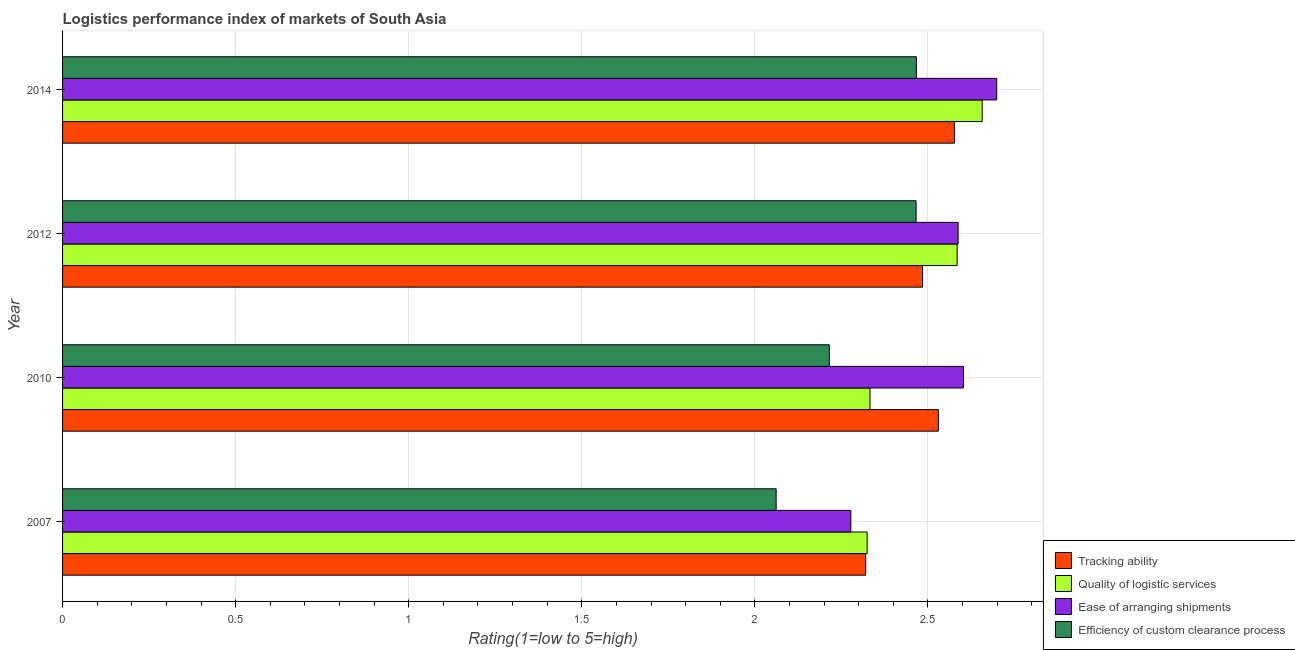How many different coloured bars are there?
Offer a very short reply. 4. How many groups of bars are there?
Provide a succinct answer. 4. How many bars are there on the 3rd tick from the bottom?
Provide a succinct answer. 4. What is the label of the 1st group of bars from the top?
Provide a succinct answer. 2014. What is the lpi rating of tracking ability in 2012?
Your answer should be very brief. 2.48. Across all years, what is the maximum lpi rating of ease of arranging shipments?
Keep it short and to the point. 2.7. Across all years, what is the minimum lpi rating of ease of arranging shipments?
Your answer should be very brief. 2.28. What is the total lpi rating of efficiency of custom clearance process in the graph?
Your answer should be compact. 9.21. What is the difference between the lpi rating of efficiency of custom clearance process in 2012 and that in 2014?
Your response must be concise. -0. What is the difference between the lpi rating of efficiency of custom clearance process in 2014 and the lpi rating of tracking ability in 2007?
Your answer should be compact. 0.15. What is the average lpi rating of quality of logistic services per year?
Ensure brevity in your answer.  2.47. In the year 2010, what is the difference between the lpi rating of quality of logistic services and lpi rating of efficiency of custom clearance process?
Make the answer very short. 0.12. In how many years, is the lpi rating of ease of arranging shipments greater than 2.5 ?
Provide a short and direct response. 3. What is the ratio of the lpi rating of efficiency of custom clearance process in 2007 to that in 2014?
Your response must be concise. 0.84. Is the lpi rating of tracking ability in 2012 less than that in 2014?
Offer a very short reply. Yes. What is the difference between the highest and the second highest lpi rating of ease of arranging shipments?
Provide a succinct answer. 0.1. What is the difference between the highest and the lowest lpi rating of tracking ability?
Provide a short and direct response. 0.26. In how many years, is the lpi rating of ease of arranging shipments greater than the average lpi rating of ease of arranging shipments taken over all years?
Make the answer very short. 3. Is it the case that in every year, the sum of the lpi rating of quality of logistic services and lpi rating of efficiency of custom clearance process is greater than the sum of lpi rating of ease of arranging shipments and lpi rating of tracking ability?
Ensure brevity in your answer.  Yes. What does the 4th bar from the top in 2012 represents?
Ensure brevity in your answer.  Tracking ability. What does the 4th bar from the bottom in 2010 represents?
Your answer should be compact. Efficiency of custom clearance process. Is it the case that in every year, the sum of the lpi rating of tracking ability and lpi rating of quality of logistic services is greater than the lpi rating of ease of arranging shipments?
Your response must be concise. Yes. Are all the bars in the graph horizontal?
Give a very brief answer. Yes. What is the difference between two consecutive major ticks on the X-axis?
Offer a terse response. 0.5. Are the values on the major ticks of X-axis written in scientific E-notation?
Make the answer very short. No. Where does the legend appear in the graph?
Your answer should be compact. Bottom right. How are the legend labels stacked?
Ensure brevity in your answer.  Vertical. What is the title of the graph?
Your response must be concise. Logistics performance index of markets of South Asia. What is the label or title of the X-axis?
Provide a short and direct response. Rating(1=low to 5=high). What is the label or title of the Y-axis?
Provide a succinct answer. Year. What is the Rating(1=low to 5=high) in Tracking ability in 2007?
Your response must be concise. 2.32. What is the Rating(1=low to 5=high) of Quality of logistic services in 2007?
Offer a very short reply. 2.32. What is the Rating(1=low to 5=high) in Ease of arranging shipments in 2007?
Your answer should be very brief. 2.28. What is the Rating(1=low to 5=high) of Efficiency of custom clearance process in 2007?
Offer a terse response. 2.06. What is the Rating(1=low to 5=high) in Tracking ability in 2010?
Give a very brief answer. 2.53. What is the Rating(1=low to 5=high) in Quality of logistic services in 2010?
Your answer should be compact. 2.33. What is the Rating(1=low to 5=high) of Ease of arranging shipments in 2010?
Provide a succinct answer. 2.6. What is the Rating(1=low to 5=high) in Efficiency of custom clearance process in 2010?
Offer a terse response. 2.21. What is the Rating(1=low to 5=high) of Tracking ability in 2012?
Ensure brevity in your answer.  2.48. What is the Rating(1=low to 5=high) in Quality of logistic services in 2012?
Your response must be concise. 2.58. What is the Rating(1=low to 5=high) in Ease of arranging shipments in 2012?
Your response must be concise. 2.59. What is the Rating(1=low to 5=high) of Efficiency of custom clearance process in 2012?
Make the answer very short. 2.47. What is the Rating(1=low to 5=high) in Tracking ability in 2014?
Provide a succinct answer. 2.58. What is the Rating(1=low to 5=high) in Quality of logistic services in 2014?
Provide a short and direct response. 2.66. What is the Rating(1=low to 5=high) in Ease of arranging shipments in 2014?
Your answer should be very brief. 2.7. What is the Rating(1=low to 5=high) in Efficiency of custom clearance process in 2014?
Give a very brief answer. 2.47. Across all years, what is the maximum Rating(1=low to 5=high) in Tracking ability?
Ensure brevity in your answer.  2.58. Across all years, what is the maximum Rating(1=low to 5=high) in Quality of logistic services?
Make the answer very short. 2.66. Across all years, what is the maximum Rating(1=low to 5=high) in Ease of arranging shipments?
Keep it short and to the point. 2.7. Across all years, what is the maximum Rating(1=low to 5=high) in Efficiency of custom clearance process?
Offer a terse response. 2.47. Across all years, what is the minimum Rating(1=low to 5=high) in Tracking ability?
Provide a succinct answer. 2.32. Across all years, what is the minimum Rating(1=low to 5=high) of Quality of logistic services?
Your answer should be very brief. 2.32. Across all years, what is the minimum Rating(1=low to 5=high) in Ease of arranging shipments?
Ensure brevity in your answer.  2.28. Across all years, what is the minimum Rating(1=low to 5=high) in Efficiency of custom clearance process?
Provide a short and direct response. 2.06. What is the total Rating(1=low to 5=high) in Tracking ability in the graph?
Provide a short and direct response. 9.91. What is the total Rating(1=low to 5=high) of Quality of logistic services in the graph?
Your response must be concise. 9.9. What is the total Rating(1=low to 5=high) in Ease of arranging shipments in the graph?
Provide a short and direct response. 10.17. What is the total Rating(1=low to 5=high) in Efficiency of custom clearance process in the graph?
Offer a terse response. 9.21. What is the difference between the Rating(1=low to 5=high) in Tracking ability in 2007 and that in 2010?
Your response must be concise. -0.21. What is the difference between the Rating(1=low to 5=high) of Quality of logistic services in 2007 and that in 2010?
Give a very brief answer. -0.01. What is the difference between the Rating(1=low to 5=high) of Ease of arranging shipments in 2007 and that in 2010?
Ensure brevity in your answer.  -0.33. What is the difference between the Rating(1=low to 5=high) in Efficiency of custom clearance process in 2007 and that in 2010?
Offer a terse response. -0.15. What is the difference between the Rating(1=low to 5=high) in Tracking ability in 2007 and that in 2012?
Keep it short and to the point. -0.16. What is the difference between the Rating(1=low to 5=high) in Quality of logistic services in 2007 and that in 2012?
Ensure brevity in your answer.  -0.26. What is the difference between the Rating(1=low to 5=high) in Ease of arranging shipments in 2007 and that in 2012?
Offer a very short reply. -0.31. What is the difference between the Rating(1=low to 5=high) of Efficiency of custom clearance process in 2007 and that in 2012?
Keep it short and to the point. -0.4. What is the difference between the Rating(1=low to 5=high) in Tracking ability in 2007 and that in 2014?
Ensure brevity in your answer.  -0.26. What is the difference between the Rating(1=low to 5=high) of Quality of logistic services in 2007 and that in 2014?
Your answer should be very brief. -0.33. What is the difference between the Rating(1=low to 5=high) in Ease of arranging shipments in 2007 and that in 2014?
Make the answer very short. -0.42. What is the difference between the Rating(1=low to 5=high) in Efficiency of custom clearance process in 2007 and that in 2014?
Your answer should be compact. -0.41. What is the difference between the Rating(1=low to 5=high) of Tracking ability in 2010 and that in 2012?
Offer a terse response. 0.05. What is the difference between the Rating(1=low to 5=high) in Quality of logistic services in 2010 and that in 2012?
Keep it short and to the point. -0.25. What is the difference between the Rating(1=low to 5=high) in Ease of arranging shipments in 2010 and that in 2012?
Make the answer very short. 0.02. What is the difference between the Rating(1=low to 5=high) of Efficiency of custom clearance process in 2010 and that in 2012?
Your answer should be compact. -0.25. What is the difference between the Rating(1=low to 5=high) of Tracking ability in 2010 and that in 2014?
Offer a terse response. -0.05. What is the difference between the Rating(1=low to 5=high) in Quality of logistic services in 2010 and that in 2014?
Make the answer very short. -0.32. What is the difference between the Rating(1=low to 5=high) of Ease of arranging shipments in 2010 and that in 2014?
Give a very brief answer. -0.1. What is the difference between the Rating(1=low to 5=high) of Efficiency of custom clearance process in 2010 and that in 2014?
Your response must be concise. -0.25. What is the difference between the Rating(1=low to 5=high) in Tracking ability in 2012 and that in 2014?
Make the answer very short. -0.09. What is the difference between the Rating(1=low to 5=high) in Quality of logistic services in 2012 and that in 2014?
Provide a short and direct response. -0.07. What is the difference between the Rating(1=low to 5=high) in Ease of arranging shipments in 2012 and that in 2014?
Offer a very short reply. -0.11. What is the difference between the Rating(1=low to 5=high) in Efficiency of custom clearance process in 2012 and that in 2014?
Keep it short and to the point. -0. What is the difference between the Rating(1=low to 5=high) in Tracking ability in 2007 and the Rating(1=low to 5=high) in Quality of logistic services in 2010?
Provide a short and direct response. -0.01. What is the difference between the Rating(1=low to 5=high) in Tracking ability in 2007 and the Rating(1=low to 5=high) in Ease of arranging shipments in 2010?
Give a very brief answer. -0.28. What is the difference between the Rating(1=low to 5=high) of Tracking ability in 2007 and the Rating(1=low to 5=high) of Efficiency of custom clearance process in 2010?
Give a very brief answer. 0.1. What is the difference between the Rating(1=low to 5=high) in Quality of logistic services in 2007 and the Rating(1=low to 5=high) in Ease of arranging shipments in 2010?
Make the answer very short. -0.28. What is the difference between the Rating(1=low to 5=high) of Quality of logistic services in 2007 and the Rating(1=low to 5=high) of Efficiency of custom clearance process in 2010?
Your answer should be very brief. 0.11. What is the difference between the Rating(1=low to 5=high) in Ease of arranging shipments in 2007 and the Rating(1=low to 5=high) in Efficiency of custom clearance process in 2010?
Provide a succinct answer. 0.06. What is the difference between the Rating(1=low to 5=high) of Tracking ability in 2007 and the Rating(1=low to 5=high) of Quality of logistic services in 2012?
Give a very brief answer. -0.26. What is the difference between the Rating(1=low to 5=high) in Tracking ability in 2007 and the Rating(1=low to 5=high) in Ease of arranging shipments in 2012?
Provide a succinct answer. -0.27. What is the difference between the Rating(1=low to 5=high) of Tracking ability in 2007 and the Rating(1=low to 5=high) of Efficiency of custom clearance process in 2012?
Your answer should be compact. -0.15. What is the difference between the Rating(1=low to 5=high) in Quality of logistic services in 2007 and the Rating(1=low to 5=high) in Ease of arranging shipments in 2012?
Give a very brief answer. -0.26. What is the difference between the Rating(1=low to 5=high) in Quality of logistic services in 2007 and the Rating(1=low to 5=high) in Efficiency of custom clearance process in 2012?
Provide a short and direct response. -0.14. What is the difference between the Rating(1=low to 5=high) in Ease of arranging shipments in 2007 and the Rating(1=low to 5=high) in Efficiency of custom clearance process in 2012?
Make the answer very short. -0.19. What is the difference between the Rating(1=low to 5=high) of Tracking ability in 2007 and the Rating(1=low to 5=high) of Quality of logistic services in 2014?
Your answer should be very brief. -0.34. What is the difference between the Rating(1=low to 5=high) of Tracking ability in 2007 and the Rating(1=low to 5=high) of Ease of arranging shipments in 2014?
Ensure brevity in your answer.  -0.38. What is the difference between the Rating(1=low to 5=high) in Tracking ability in 2007 and the Rating(1=low to 5=high) in Efficiency of custom clearance process in 2014?
Your answer should be compact. -0.15. What is the difference between the Rating(1=low to 5=high) of Quality of logistic services in 2007 and the Rating(1=low to 5=high) of Ease of arranging shipments in 2014?
Provide a short and direct response. -0.37. What is the difference between the Rating(1=low to 5=high) in Quality of logistic services in 2007 and the Rating(1=low to 5=high) in Efficiency of custom clearance process in 2014?
Keep it short and to the point. -0.14. What is the difference between the Rating(1=low to 5=high) in Ease of arranging shipments in 2007 and the Rating(1=low to 5=high) in Efficiency of custom clearance process in 2014?
Keep it short and to the point. -0.19. What is the difference between the Rating(1=low to 5=high) of Tracking ability in 2010 and the Rating(1=low to 5=high) of Quality of logistic services in 2012?
Offer a terse response. -0.05. What is the difference between the Rating(1=low to 5=high) of Tracking ability in 2010 and the Rating(1=low to 5=high) of Ease of arranging shipments in 2012?
Offer a very short reply. -0.06. What is the difference between the Rating(1=low to 5=high) of Tracking ability in 2010 and the Rating(1=low to 5=high) of Efficiency of custom clearance process in 2012?
Keep it short and to the point. 0.06. What is the difference between the Rating(1=low to 5=high) of Quality of logistic services in 2010 and the Rating(1=low to 5=high) of Ease of arranging shipments in 2012?
Offer a very short reply. -0.25. What is the difference between the Rating(1=low to 5=high) in Quality of logistic services in 2010 and the Rating(1=low to 5=high) in Efficiency of custom clearance process in 2012?
Your answer should be very brief. -0.13. What is the difference between the Rating(1=low to 5=high) of Ease of arranging shipments in 2010 and the Rating(1=low to 5=high) of Efficiency of custom clearance process in 2012?
Provide a short and direct response. 0.14. What is the difference between the Rating(1=low to 5=high) in Tracking ability in 2010 and the Rating(1=low to 5=high) in Quality of logistic services in 2014?
Keep it short and to the point. -0.13. What is the difference between the Rating(1=low to 5=high) in Tracking ability in 2010 and the Rating(1=low to 5=high) in Ease of arranging shipments in 2014?
Provide a succinct answer. -0.17. What is the difference between the Rating(1=low to 5=high) of Tracking ability in 2010 and the Rating(1=low to 5=high) of Efficiency of custom clearance process in 2014?
Your answer should be very brief. 0.06. What is the difference between the Rating(1=low to 5=high) in Quality of logistic services in 2010 and the Rating(1=low to 5=high) in Ease of arranging shipments in 2014?
Offer a very short reply. -0.37. What is the difference between the Rating(1=low to 5=high) in Quality of logistic services in 2010 and the Rating(1=low to 5=high) in Efficiency of custom clearance process in 2014?
Make the answer very short. -0.13. What is the difference between the Rating(1=low to 5=high) of Ease of arranging shipments in 2010 and the Rating(1=low to 5=high) of Efficiency of custom clearance process in 2014?
Your response must be concise. 0.14. What is the difference between the Rating(1=low to 5=high) of Tracking ability in 2012 and the Rating(1=low to 5=high) of Quality of logistic services in 2014?
Offer a terse response. -0.17. What is the difference between the Rating(1=low to 5=high) of Tracking ability in 2012 and the Rating(1=low to 5=high) of Ease of arranging shipments in 2014?
Provide a short and direct response. -0.21. What is the difference between the Rating(1=low to 5=high) in Tracking ability in 2012 and the Rating(1=low to 5=high) in Efficiency of custom clearance process in 2014?
Make the answer very short. 0.02. What is the difference between the Rating(1=low to 5=high) in Quality of logistic services in 2012 and the Rating(1=low to 5=high) in Ease of arranging shipments in 2014?
Provide a succinct answer. -0.11. What is the difference between the Rating(1=low to 5=high) in Quality of logistic services in 2012 and the Rating(1=low to 5=high) in Efficiency of custom clearance process in 2014?
Offer a very short reply. 0.12. What is the difference between the Rating(1=low to 5=high) of Ease of arranging shipments in 2012 and the Rating(1=low to 5=high) of Efficiency of custom clearance process in 2014?
Offer a very short reply. 0.12. What is the average Rating(1=low to 5=high) in Tracking ability per year?
Provide a short and direct response. 2.48. What is the average Rating(1=low to 5=high) of Quality of logistic services per year?
Make the answer very short. 2.47. What is the average Rating(1=low to 5=high) in Ease of arranging shipments per year?
Offer a terse response. 2.54. What is the average Rating(1=low to 5=high) in Efficiency of custom clearance process per year?
Give a very brief answer. 2.3. In the year 2007, what is the difference between the Rating(1=low to 5=high) in Tracking ability and Rating(1=low to 5=high) in Quality of logistic services?
Your response must be concise. -0. In the year 2007, what is the difference between the Rating(1=low to 5=high) in Tracking ability and Rating(1=low to 5=high) in Ease of arranging shipments?
Offer a very short reply. 0.04. In the year 2007, what is the difference between the Rating(1=low to 5=high) of Tracking ability and Rating(1=low to 5=high) of Efficiency of custom clearance process?
Keep it short and to the point. 0.26. In the year 2007, what is the difference between the Rating(1=low to 5=high) of Quality of logistic services and Rating(1=low to 5=high) of Ease of arranging shipments?
Give a very brief answer. 0.05. In the year 2007, what is the difference between the Rating(1=low to 5=high) of Quality of logistic services and Rating(1=low to 5=high) of Efficiency of custom clearance process?
Your answer should be very brief. 0.26. In the year 2007, what is the difference between the Rating(1=low to 5=high) of Ease of arranging shipments and Rating(1=low to 5=high) of Efficiency of custom clearance process?
Make the answer very short. 0.22. In the year 2010, what is the difference between the Rating(1=low to 5=high) in Tracking ability and Rating(1=low to 5=high) in Quality of logistic services?
Keep it short and to the point. 0.2. In the year 2010, what is the difference between the Rating(1=low to 5=high) in Tracking ability and Rating(1=low to 5=high) in Ease of arranging shipments?
Provide a short and direct response. -0.07. In the year 2010, what is the difference between the Rating(1=low to 5=high) of Tracking ability and Rating(1=low to 5=high) of Efficiency of custom clearance process?
Provide a short and direct response. 0.32. In the year 2010, what is the difference between the Rating(1=low to 5=high) of Quality of logistic services and Rating(1=low to 5=high) of Ease of arranging shipments?
Offer a terse response. -0.27. In the year 2010, what is the difference between the Rating(1=low to 5=high) in Quality of logistic services and Rating(1=low to 5=high) in Efficiency of custom clearance process?
Your response must be concise. 0.12. In the year 2010, what is the difference between the Rating(1=low to 5=high) of Ease of arranging shipments and Rating(1=low to 5=high) of Efficiency of custom clearance process?
Provide a succinct answer. 0.39. In the year 2012, what is the difference between the Rating(1=low to 5=high) in Tracking ability and Rating(1=low to 5=high) in Quality of logistic services?
Keep it short and to the point. -0.1. In the year 2012, what is the difference between the Rating(1=low to 5=high) of Tracking ability and Rating(1=low to 5=high) of Ease of arranging shipments?
Make the answer very short. -0.1. In the year 2012, what is the difference between the Rating(1=low to 5=high) of Tracking ability and Rating(1=low to 5=high) of Efficiency of custom clearance process?
Offer a very short reply. 0.02. In the year 2012, what is the difference between the Rating(1=low to 5=high) of Quality of logistic services and Rating(1=low to 5=high) of Ease of arranging shipments?
Your response must be concise. -0. In the year 2012, what is the difference between the Rating(1=low to 5=high) of Quality of logistic services and Rating(1=low to 5=high) of Efficiency of custom clearance process?
Provide a short and direct response. 0.12. In the year 2012, what is the difference between the Rating(1=low to 5=high) in Ease of arranging shipments and Rating(1=low to 5=high) in Efficiency of custom clearance process?
Your response must be concise. 0.12. In the year 2014, what is the difference between the Rating(1=low to 5=high) of Tracking ability and Rating(1=low to 5=high) of Quality of logistic services?
Offer a very short reply. -0.08. In the year 2014, what is the difference between the Rating(1=low to 5=high) in Tracking ability and Rating(1=low to 5=high) in Ease of arranging shipments?
Keep it short and to the point. -0.12. In the year 2014, what is the difference between the Rating(1=low to 5=high) of Tracking ability and Rating(1=low to 5=high) of Efficiency of custom clearance process?
Keep it short and to the point. 0.11. In the year 2014, what is the difference between the Rating(1=low to 5=high) of Quality of logistic services and Rating(1=low to 5=high) of Ease of arranging shipments?
Provide a succinct answer. -0.04. In the year 2014, what is the difference between the Rating(1=low to 5=high) of Quality of logistic services and Rating(1=low to 5=high) of Efficiency of custom clearance process?
Make the answer very short. 0.19. In the year 2014, what is the difference between the Rating(1=low to 5=high) in Ease of arranging shipments and Rating(1=low to 5=high) in Efficiency of custom clearance process?
Provide a succinct answer. 0.23. What is the ratio of the Rating(1=low to 5=high) of Tracking ability in 2007 to that in 2010?
Ensure brevity in your answer.  0.92. What is the ratio of the Rating(1=low to 5=high) in Ease of arranging shipments in 2007 to that in 2010?
Keep it short and to the point. 0.88. What is the ratio of the Rating(1=low to 5=high) of Efficiency of custom clearance process in 2007 to that in 2010?
Your answer should be very brief. 0.93. What is the ratio of the Rating(1=low to 5=high) of Tracking ability in 2007 to that in 2012?
Give a very brief answer. 0.93. What is the ratio of the Rating(1=low to 5=high) in Quality of logistic services in 2007 to that in 2012?
Your answer should be compact. 0.9. What is the ratio of the Rating(1=low to 5=high) in Ease of arranging shipments in 2007 to that in 2012?
Offer a very short reply. 0.88. What is the ratio of the Rating(1=low to 5=high) of Efficiency of custom clearance process in 2007 to that in 2012?
Your response must be concise. 0.84. What is the ratio of the Rating(1=low to 5=high) in Tracking ability in 2007 to that in 2014?
Offer a terse response. 0.9. What is the ratio of the Rating(1=low to 5=high) of Quality of logistic services in 2007 to that in 2014?
Provide a short and direct response. 0.87. What is the ratio of the Rating(1=low to 5=high) of Ease of arranging shipments in 2007 to that in 2014?
Give a very brief answer. 0.84. What is the ratio of the Rating(1=low to 5=high) in Efficiency of custom clearance process in 2007 to that in 2014?
Your response must be concise. 0.84. What is the ratio of the Rating(1=low to 5=high) in Tracking ability in 2010 to that in 2012?
Offer a terse response. 1.02. What is the ratio of the Rating(1=low to 5=high) of Quality of logistic services in 2010 to that in 2012?
Keep it short and to the point. 0.9. What is the ratio of the Rating(1=low to 5=high) in Ease of arranging shipments in 2010 to that in 2012?
Make the answer very short. 1.01. What is the ratio of the Rating(1=low to 5=high) of Efficiency of custom clearance process in 2010 to that in 2012?
Offer a terse response. 0.9. What is the ratio of the Rating(1=low to 5=high) in Quality of logistic services in 2010 to that in 2014?
Provide a succinct answer. 0.88. What is the ratio of the Rating(1=low to 5=high) of Ease of arranging shipments in 2010 to that in 2014?
Your answer should be compact. 0.96. What is the ratio of the Rating(1=low to 5=high) of Efficiency of custom clearance process in 2010 to that in 2014?
Offer a terse response. 0.9. What is the ratio of the Rating(1=low to 5=high) of Quality of logistic services in 2012 to that in 2014?
Your response must be concise. 0.97. What is the ratio of the Rating(1=low to 5=high) in Ease of arranging shipments in 2012 to that in 2014?
Keep it short and to the point. 0.96. What is the ratio of the Rating(1=low to 5=high) of Efficiency of custom clearance process in 2012 to that in 2014?
Keep it short and to the point. 1. What is the difference between the highest and the second highest Rating(1=low to 5=high) in Tracking ability?
Ensure brevity in your answer.  0.05. What is the difference between the highest and the second highest Rating(1=low to 5=high) of Quality of logistic services?
Provide a succinct answer. 0.07. What is the difference between the highest and the second highest Rating(1=low to 5=high) of Ease of arranging shipments?
Offer a very short reply. 0.1. What is the difference between the highest and the second highest Rating(1=low to 5=high) in Efficiency of custom clearance process?
Give a very brief answer. 0. What is the difference between the highest and the lowest Rating(1=low to 5=high) in Tracking ability?
Ensure brevity in your answer.  0.26. What is the difference between the highest and the lowest Rating(1=low to 5=high) in Quality of logistic services?
Keep it short and to the point. 0.33. What is the difference between the highest and the lowest Rating(1=low to 5=high) in Ease of arranging shipments?
Give a very brief answer. 0.42. What is the difference between the highest and the lowest Rating(1=low to 5=high) of Efficiency of custom clearance process?
Your answer should be very brief. 0.41. 